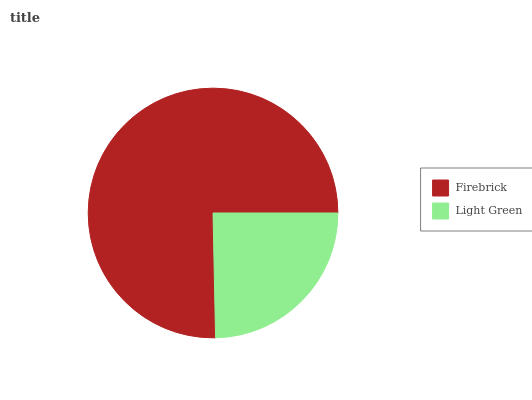Is Light Green the minimum?
Answer yes or no. Yes. Is Firebrick the maximum?
Answer yes or no. Yes. Is Light Green the maximum?
Answer yes or no. No. Is Firebrick greater than Light Green?
Answer yes or no. Yes. Is Light Green less than Firebrick?
Answer yes or no. Yes. Is Light Green greater than Firebrick?
Answer yes or no. No. Is Firebrick less than Light Green?
Answer yes or no. No. Is Firebrick the high median?
Answer yes or no. Yes. Is Light Green the low median?
Answer yes or no. Yes. Is Light Green the high median?
Answer yes or no. No. Is Firebrick the low median?
Answer yes or no. No. 